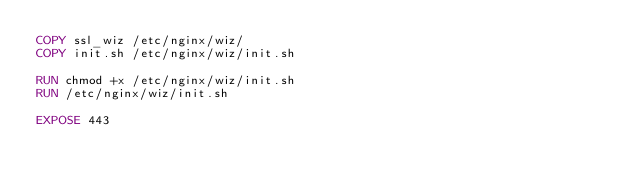<code> <loc_0><loc_0><loc_500><loc_500><_Dockerfile_>COPY ssl_wiz /etc/nginx/wiz/
COPY init.sh /etc/nginx/wiz/init.sh

RUN chmod +x /etc/nginx/wiz/init.sh
RUN /etc/nginx/wiz/init.sh

EXPOSE 443
</code> 